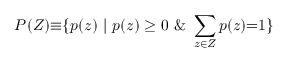Convert formula to latex. <formula><loc_0><loc_0><loc_500><loc_500>P ( Z ) { \equiv } \{ p ( z ) | p ( z ) \geq 0 \& \sum _ { z \in Z } p ( z ) { = } 1 \}</formula> 